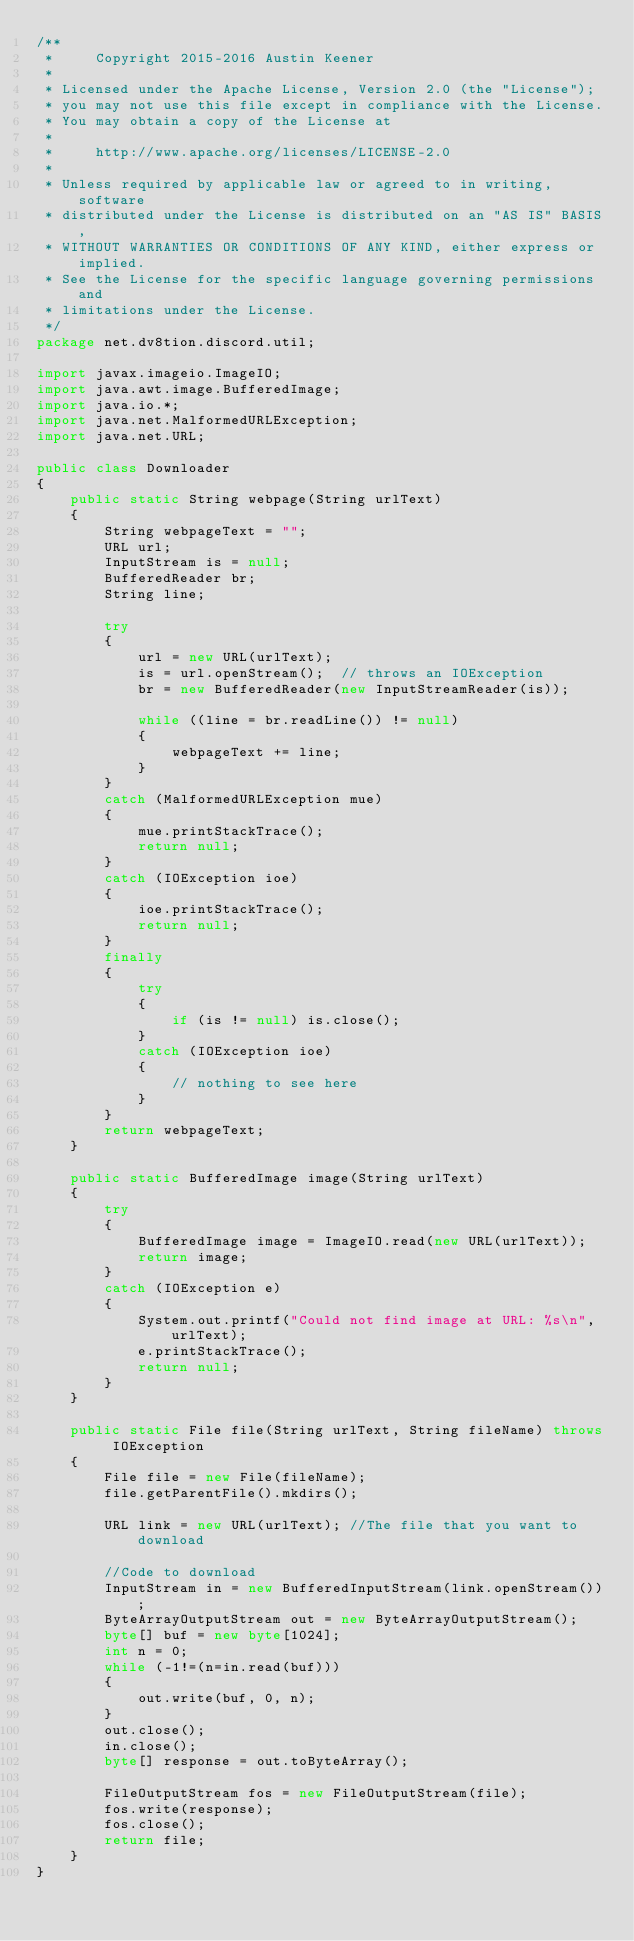<code> <loc_0><loc_0><loc_500><loc_500><_Java_>/**
 *     Copyright 2015-2016 Austin Keener
 *
 * Licensed under the Apache License, Version 2.0 (the "License");
 * you may not use this file except in compliance with the License.
 * You may obtain a copy of the License at
 *
 *     http://www.apache.org/licenses/LICENSE-2.0
 *
 * Unless required by applicable law or agreed to in writing, software
 * distributed under the License is distributed on an "AS IS" BASIS,
 * WITHOUT WARRANTIES OR CONDITIONS OF ANY KIND, either express or implied.
 * See the License for the specific language governing permissions and
 * limitations under the License.
 */
package net.dv8tion.discord.util;

import javax.imageio.ImageIO;
import java.awt.image.BufferedImage;
import java.io.*;
import java.net.MalformedURLException;
import java.net.URL;

public class Downloader
{
    public static String webpage(String urlText)
    {
        String webpageText = "";
        URL url;
        InputStream is = null;
        BufferedReader br;
        String line;

        try
        {
            url = new URL(urlText);
            is = url.openStream();  // throws an IOException
            br = new BufferedReader(new InputStreamReader(is));

            while ((line = br.readLine()) != null)
            {
                webpageText += line;
            }
        }
        catch (MalformedURLException mue)
        {
            mue.printStackTrace();
            return null;
        }
        catch (IOException ioe)
        {
            ioe.printStackTrace();
            return null;
        }
        finally
        {
            try
            {
                if (is != null) is.close();
            }
            catch (IOException ioe)
            {
                // nothing to see here
            }
        }
        return webpageText;
    }

    public static BufferedImage image(String urlText)
    {
        try
        {
            BufferedImage image = ImageIO.read(new URL(urlText));
            return image;
        }
        catch (IOException e)
        {
            System.out.printf("Could not find image at URL: %s\n", urlText);
            e.printStackTrace();
            return null;
        }
    }

    public static File file(String urlText, String fileName) throws IOException
    {
        File file = new File(fileName);
        file.getParentFile().mkdirs();

        URL link = new URL(urlText); //The file that you want to download

        //Code to download
        InputStream in = new BufferedInputStream(link.openStream());
        ByteArrayOutputStream out = new ByteArrayOutputStream();
        byte[] buf = new byte[1024];
        int n = 0;
        while (-1!=(n=in.read(buf)))
        {
            out.write(buf, 0, n);
        }
        out.close();
        in.close();
        byte[] response = out.toByteArray();

        FileOutputStream fos = new FileOutputStream(file);
        fos.write(response);
        fos.close();
        return file;
    }
}
</code> 